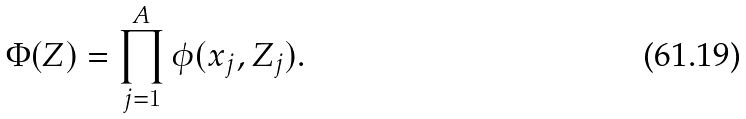<formula> <loc_0><loc_0><loc_500><loc_500>\Phi ( Z ) = \prod _ { j = 1 } ^ { A } \phi ( x _ { j } , Z _ { j } ) .</formula> 